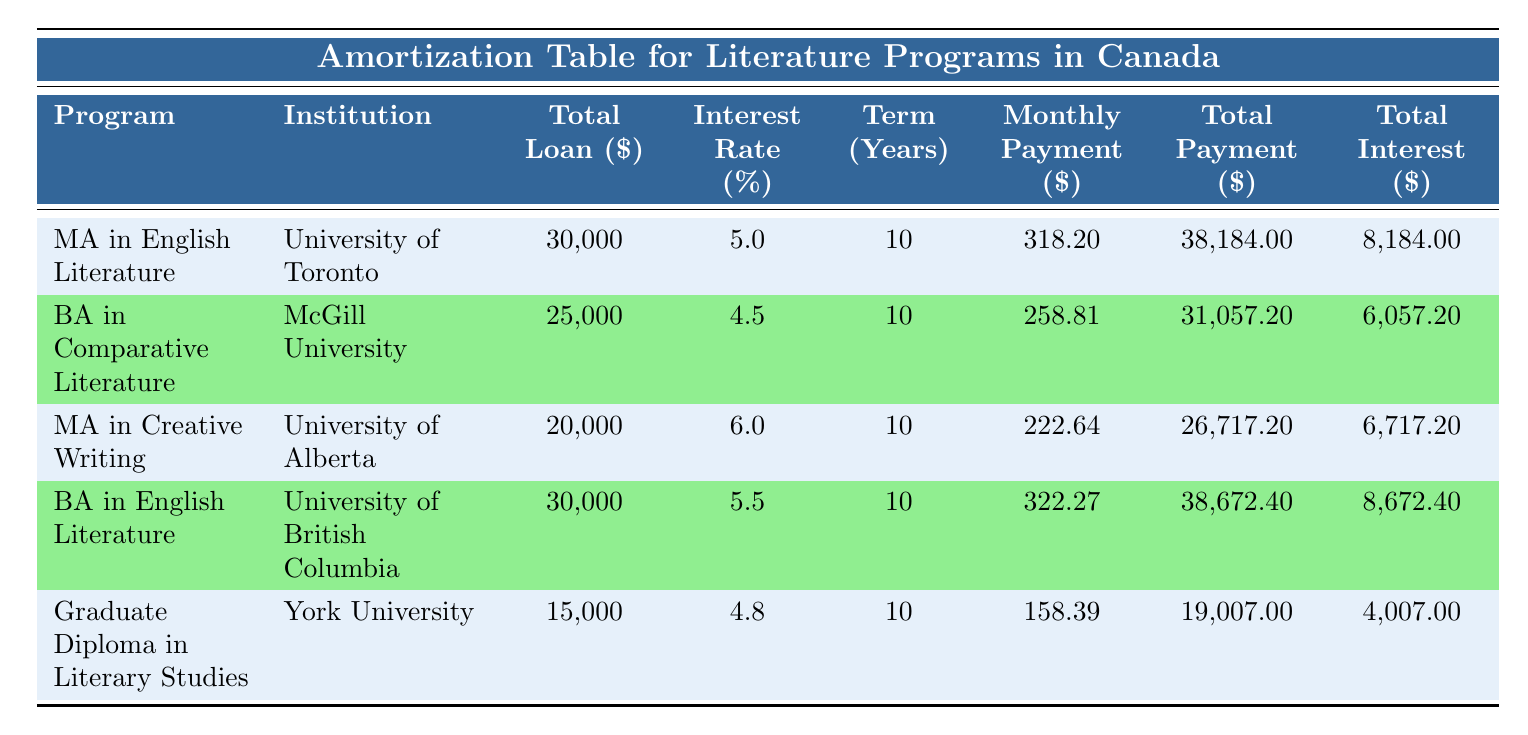What is the total loan amount for the Master's program in English Literature? The table shows the total loan amount under the column "Total Loan ($)" for the "Master of Arts in English Literature" program, which is listed as 30,000.
Answer: 30,000 Which institution offers the Bachelor of Arts in Comparative Literature? The table lists "McGill University" in the row associated with the "BA in Comparative Literature" program, indicating that it is the offering institution.
Answer: McGill University What is the total interest paid for the Graduate Diploma in Literary Studies? Under the column "Total Interest ($)" for the "Graduate Diploma in Literary Studies," the value shown is 4,007, showing the total interest paid for the loan.
Answer: 4,007 What are the average monthly payments for the two Master's programs? First, we identify the monthly payments for both Master's programs: MA in English Literature (318.20) and MA in Creative Writing (222.64). The total is 318.20 + 222.64 = 540.84. Dividing by 2 gives us an average: 540.84 / 2 = 270.42.
Answer: 270.42 Is the total payment for the Bachelor of Arts in English Literature greater than the total payment for the Graduate Diploma in Literary Studies? The total payment for the "BA in English Literature" is 38,672.40, and for the "Graduate Diploma in Literary Studies," it is 19,007. Since 38,672.40 is greater than 19,007, the statement is true.
Answer: Yes What is the difference in total payment between the Bachelor of Arts in Comparative Literature and the Master's program in Creative Writing? The total payment for the "BA in Comparative Literature" is 31,057.20 and for the "MA in Creative Writing" it is 26,717.20. The difference is 31,057.20 - 26,717.20 = 4,340.
Answer: 4,340 Which program has the highest total interest paid? By checking the "Total Interest ($)" column, the values are: 8,184 for MA in English Literature, 6,057.20 for BA in Comparative Literature, 6,717.20 for MA in Creative Writing, 8,672.40 for BA in English Literature, and 4,007 for the Graduate Diploma. The highest value is 8,672.40 for BA in English Literature.
Answer: BA in English Literature Does the University of Alberta have a program with a monthly payment over 250? The monthly payment for the "MA in Creative Writing" at the University of Alberta is 222.64, which is less than 250. Thus, there is no program meeting that criterion.
Answer: No 